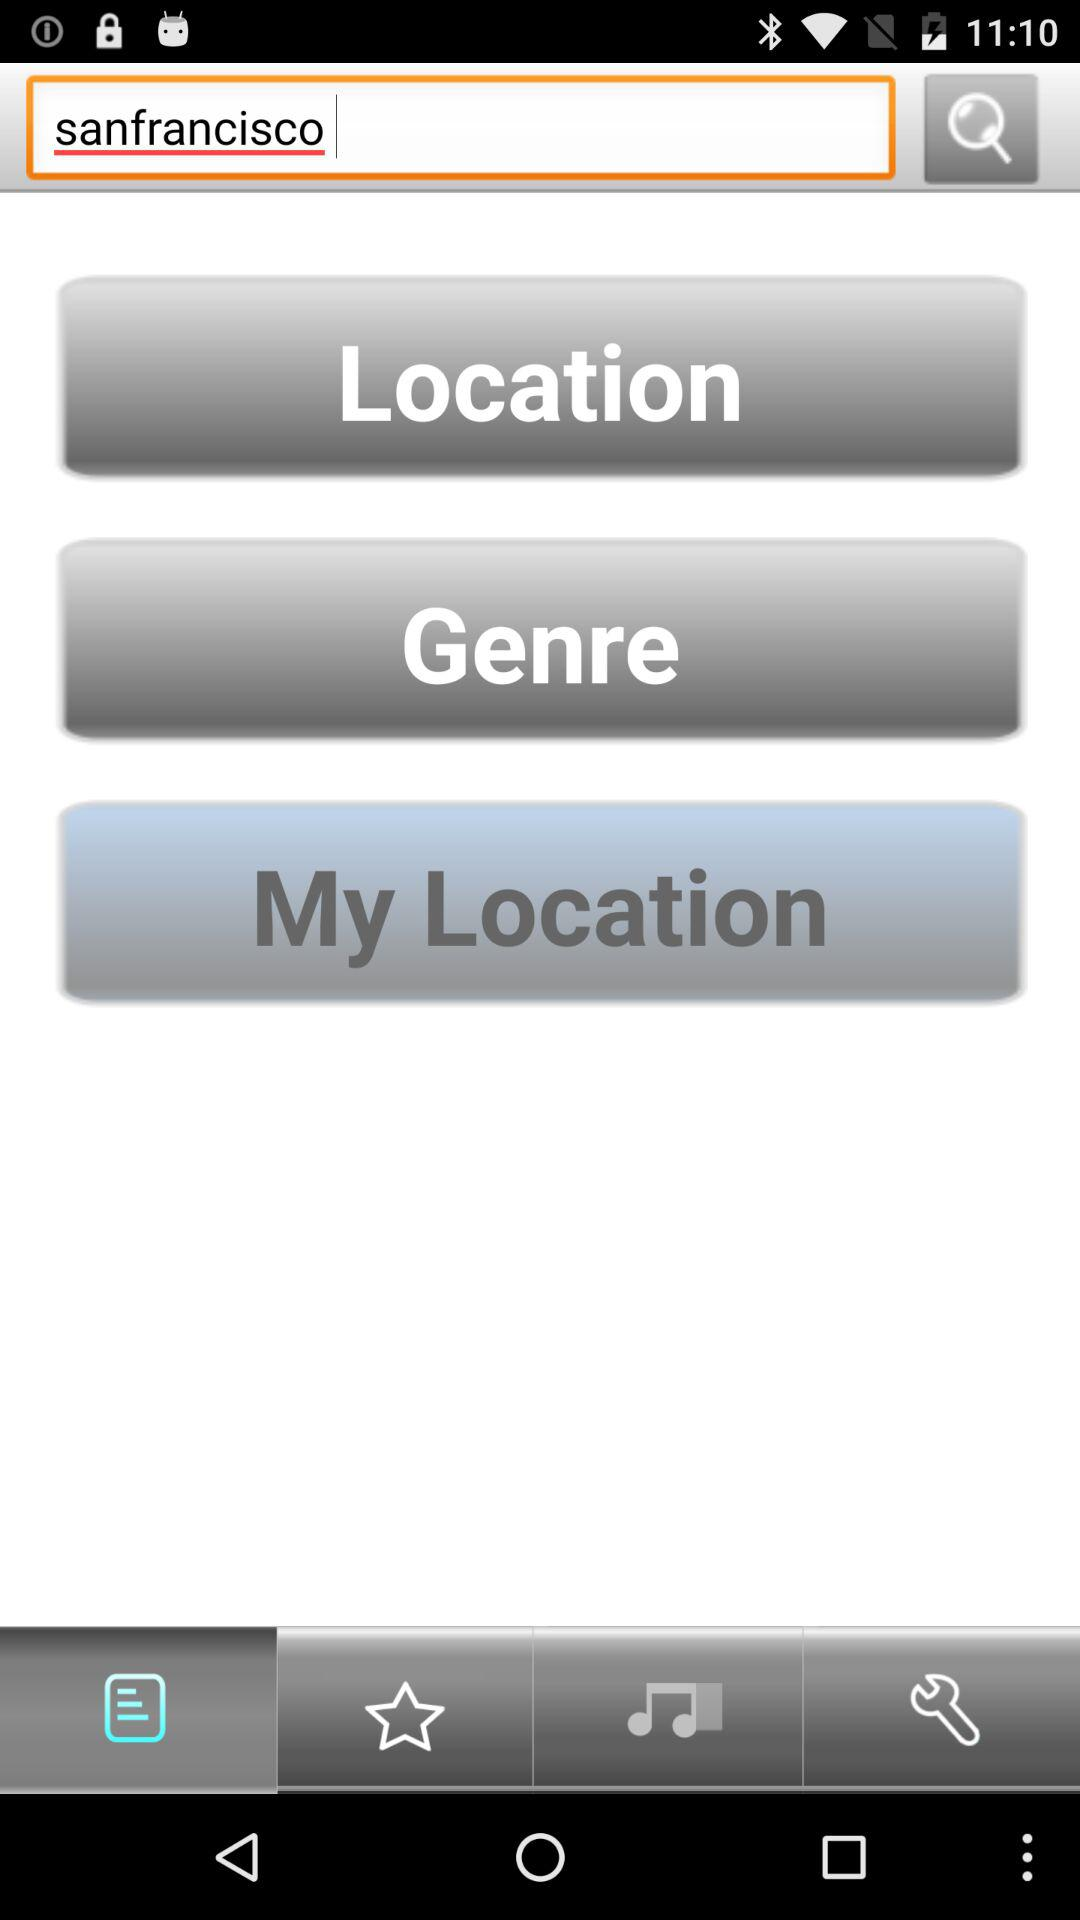Which option is selected? The selected option is "List". 